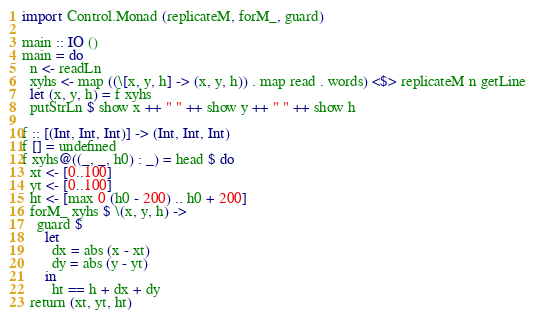<code> <loc_0><loc_0><loc_500><loc_500><_Haskell_>import Control.Monad (replicateM, forM_, guard)

main :: IO ()
main = do
  n <- readLn
  xyhs <- map ((\[x, y, h] -> (x, y, h)) . map read . words) <$> replicateM n getLine
  let (x, y, h) = f xyhs
  putStrLn $ show x ++ " " ++ show y ++ " " ++ show h

f :: [(Int, Int, Int)] -> (Int, Int, Int)
f [] = undefined
f xyhs@((_, _, h0) : _) = head $ do
  xt <- [0..100]
  yt <- [0..100]
  ht <- [max 0 (h0 - 200) .. h0 + 200]
  forM_ xyhs $ \(x, y, h) ->
    guard $
      let
        dx = abs (x - xt)
        dy = abs (y - yt)
      in
        ht == h + dx + dy
  return (xt, yt, ht)
</code> 